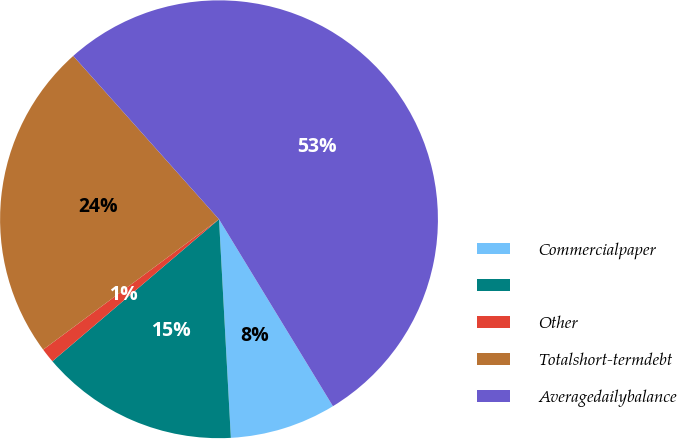<chart> <loc_0><loc_0><loc_500><loc_500><pie_chart><fcel>Commercialpaper<fcel>Unnamed: 1<fcel>Other<fcel>Totalshort-termdebt<fcel>Averagedailybalance<nl><fcel>7.85%<fcel>14.63%<fcel>1.08%<fcel>23.56%<fcel>52.89%<nl></chart> 